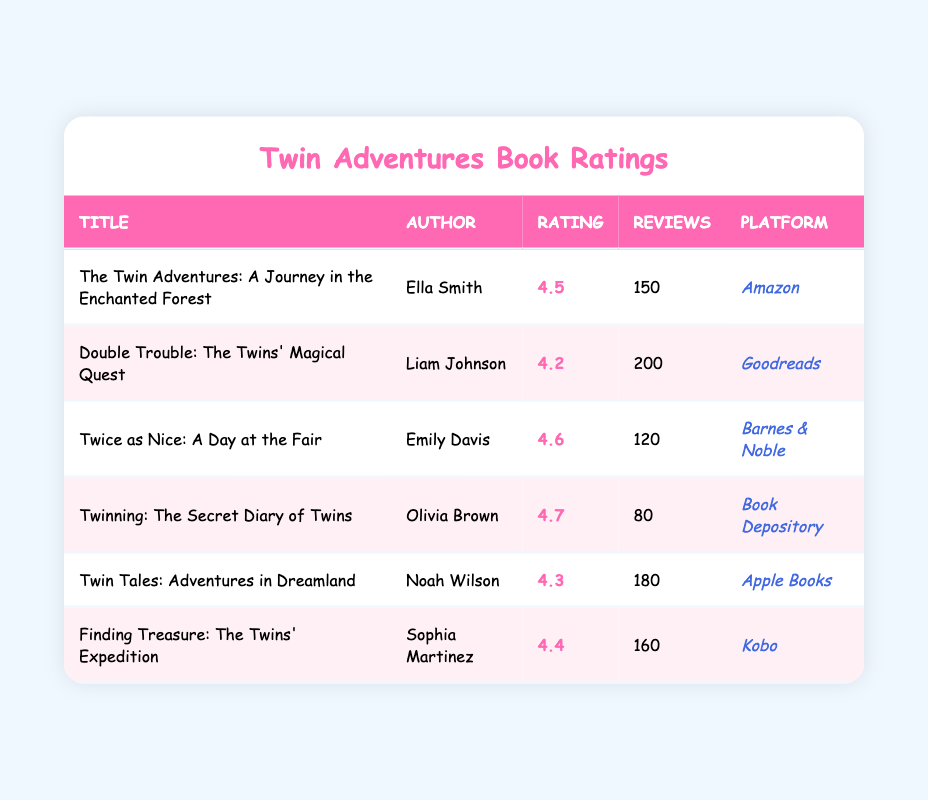What is the title of the book with the highest average rating? The table shows the average ratings for each book. By inspecting the "Rating" column, "Twinning: The Secret Diary of Twins" has the highest rating of 4.7.
Answer: Twinning: The Secret Diary of Twins Which book has the most reviews, and how many reviews does it have? By reviewing the "Reviews" column in the table, "Double Trouble: The Twins' Magical Quest" has the highest number with 200 reviews.
Answer: Double Trouble: The Twins' Magical Quest, 200 reviews Calculate the average rating of all the books listed. First, we sum the ratings of all six books: 4.5 + 4.2 + 4.6 + 4.7 + 4.3 + 4.4 = 26.7. Then we divide by the number of books (6). The average rating is 26.7 / 6 = 4.45.
Answer: 4.45 Is there a book authored by Noah Wilson? By scanning the "Author" column, we confirm that "Noah Wilson" is indeed the author of "Twin Tales: Adventures in Dreamland."
Answer: Yes What is the difference in the number of reviews between the book with the highest rating and the one with the lowest rating? The highest-rated book is "Twinning: The Secret Diary of Twins," which has 80 reviews, and the lowest-rated book is "Double Trouble: The Twins' Magical Quest," which has 200 reviews. The difference is 200 - 80 = 120.
Answer: 120 reviews Which book has the lowest average rating and how many reviews does it have? Using the "Rating" column, the lowest rating is 4.2 from "Double Trouble: The Twins' Magical Quest," which has 200 reviews.
Answer: Double Trouble: The Twins' Magical Quest, 200 reviews How many platforms are represented in the table? Looking at the "Platform" column, we see that there are six different platforms listed: Amazon, Goodreads, Barnes & Noble, Book Depository, Apple Books, and Kobo. Thus, there are 6 platforms.
Answer: 6 platforms Which author has written a book that has received more than 160 reviews? Inspecting the "Reviews" column, "Double Trouble: The Twins' Magical Quest" by Liam Johnson (200 reviews) and "Finding Treasure: The Twins' Expedition" by Sophia Martinez (160 reviews) meet the criterion. The author who has a book with more than 160 reviews is Liam Johnson.
Answer: Liam Johnson 